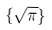Convert formula to latex. <formula><loc_0><loc_0><loc_500><loc_500>\{ \sqrt { \pi } \}</formula> 